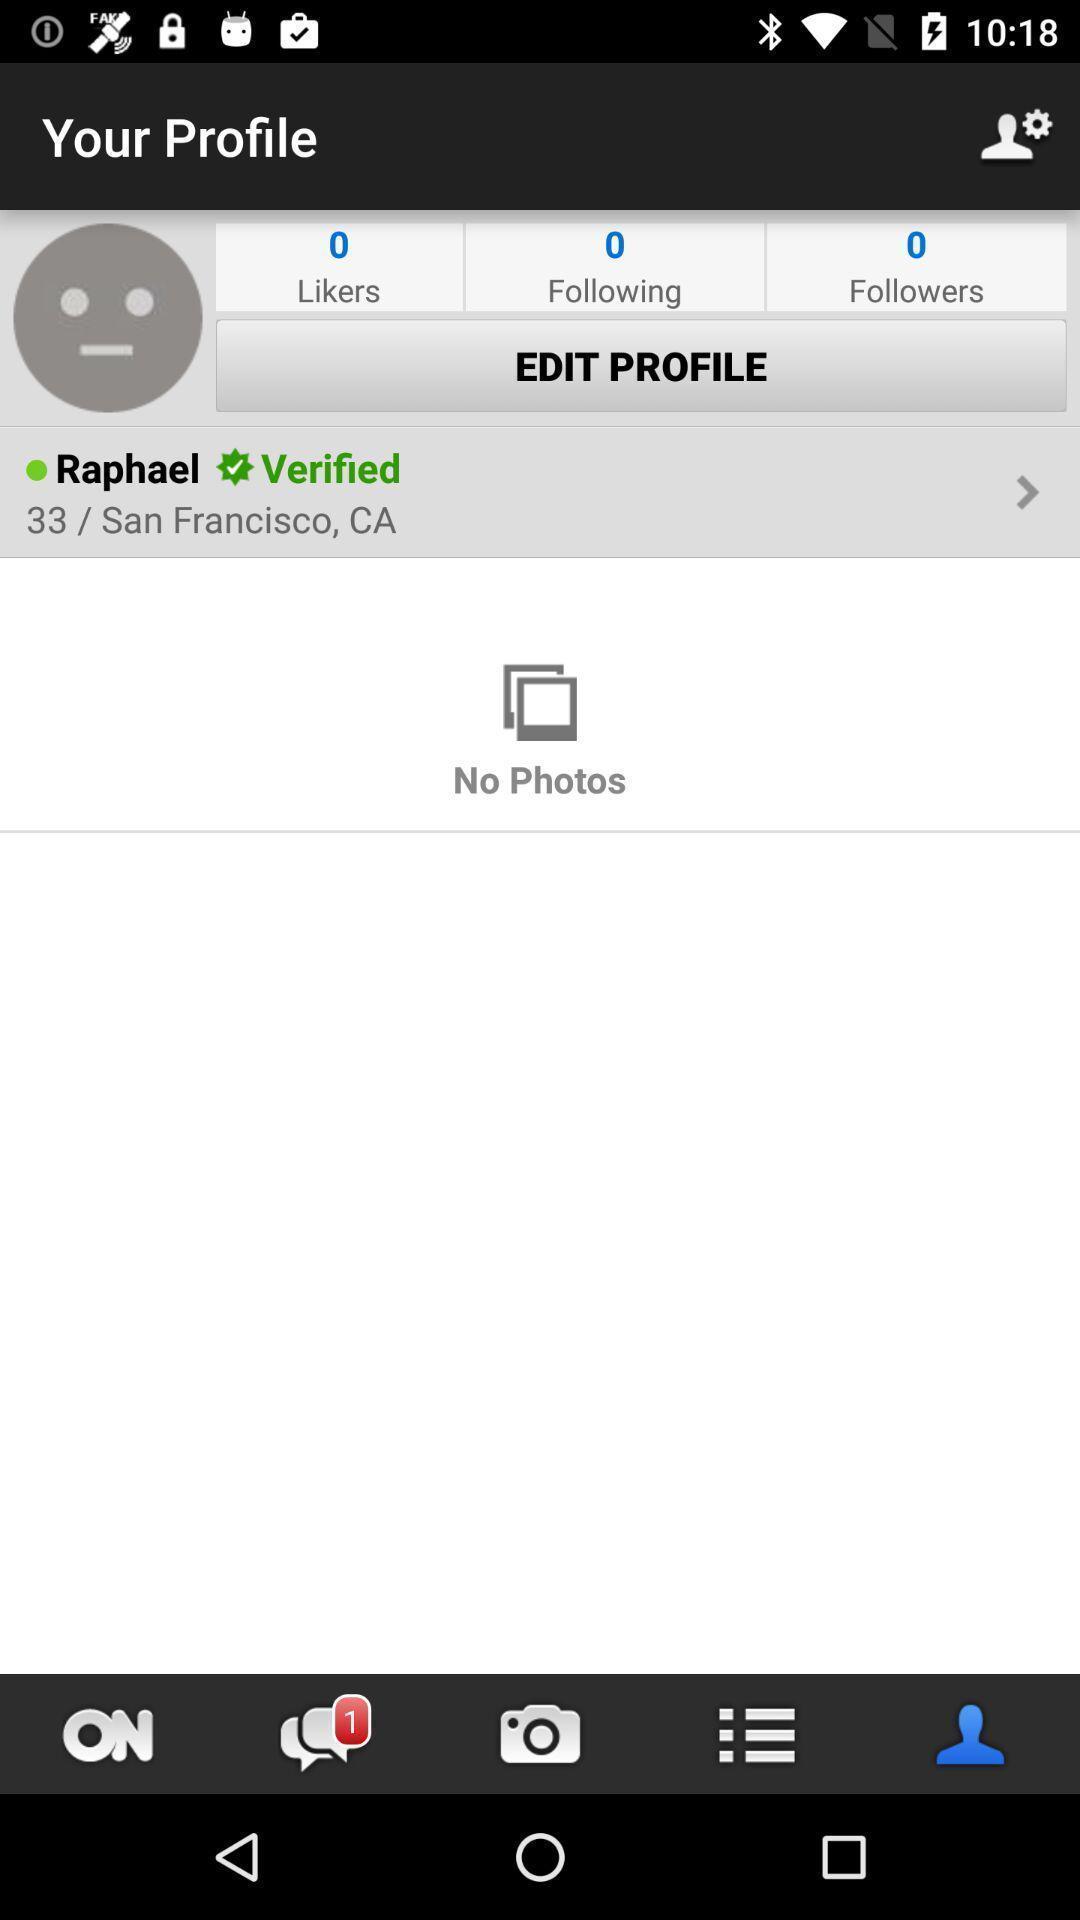Summarize the main components in this picture. Profile page. 